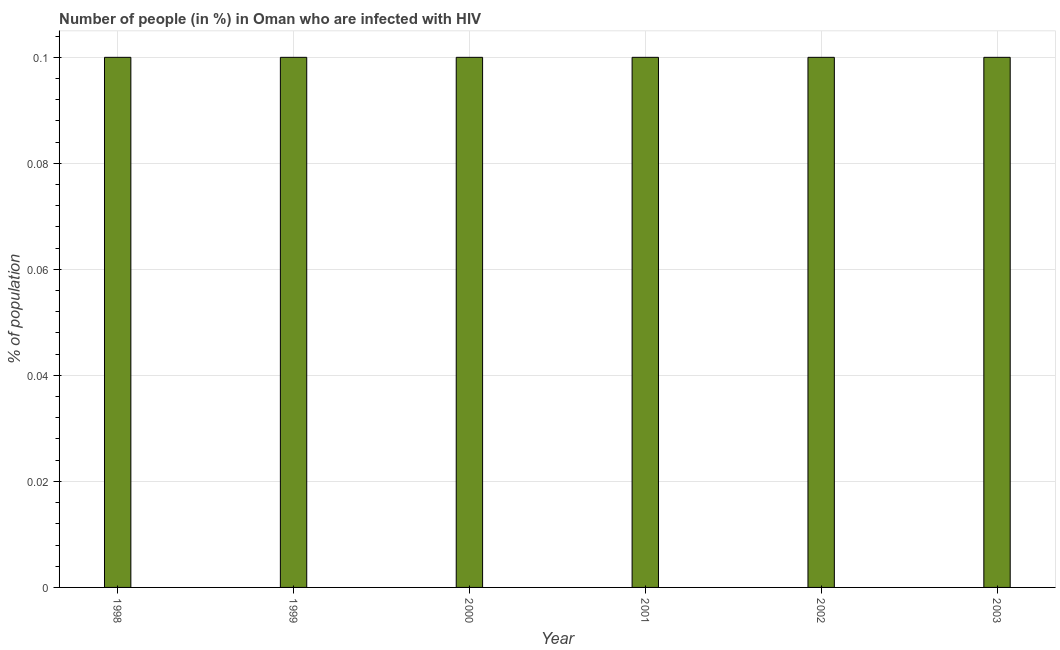Does the graph contain any zero values?
Provide a short and direct response. No. Does the graph contain grids?
Ensure brevity in your answer.  Yes. What is the title of the graph?
Offer a terse response. Number of people (in %) in Oman who are infected with HIV. What is the label or title of the Y-axis?
Provide a short and direct response. % of population. What is the number of people infected with hiv in 2000?
Make the answer very short. 0.1. Across all years, what is the minimum number of people infected with hiv?
Provide a succinct answer. 0.1. In which year was the number of people infected with hiv maximum?
Make the answer very short. 1998. In which year was the number of people infected with hiv minimum?
Offer a terse response. 1998. What is the sum of the number of people infected with hiv?
Your answer should be compact. 0.6. What is the average number of people infected with hiv per year?
Your answer should be compact. 0.1. What is the median number of people infected with hiv?
Your answer should be very brief. 0.1. Do a majority of the years between 2002 and 2000 (inclusive) have number of people infected with hiv greater than 0.044 %?
Ensure brevity in your answer.  Yes. Is the difference between the number of people infected with hiv in 1998 and 2003 greater than the difference between any two years?
Make the answer very short. Yes. What is the difference between two consecutive major ticks on the Y-axis?
Give a very brief answer. 0.02. Are the values on the major ticks of Y-axis written in scientific E-notation?
Give a very brief answer. No. What is the % of population of 1998?
Your answer should be compact. 0.1. What is the % of population of 2000?
Offer a very short reply. 0.1. What is the % of population in 2002?
Give a very brief answer. 0.1. What is the % of population in 2003?
Ensure brevity in your answer.  0.1. What is the difference between the % of population in 1998 and 2001?
Offer a very short reply. 0. What is the difference between the % of population in 1999 and 2001?
Your answer should be very brief. 0. What is the difference between the % of population in 1999 and 2002?
Your response must be concise. 0. What is the difference between the % of population in 1999 and 2003?
Provide a succinct answer. 0. What is the difference between the % of population in 2000 and 2001?
Offer a very short reply. 0. What is the difference between the % of population in 2001 and 2003?
Your answer should be very brief. 0. What is the difference between the % of population in 2002 and 2003?
Ensure brevity in your answer.  0. What is the ratio of the % of population in 1998 to that in 2003?
Provide a succinct answer. 1. What is the ratio of the % of population in 1999 to that in 2001?
Your answer should be very brief. 1. What is the ratio of the % of population in 1999 to that in 2002?
Make the answer very short. 1. What is the ratio of the % of population in 1999 to that in 2003?
Keep it short and to the point. 1. What is the ratio of the % of population in 2000 to that in 2003?
Provide a succinct answer. 1. What is the ratio of the % of population in 2001 to that in 2003?
Keep it short and to the point. 1. 